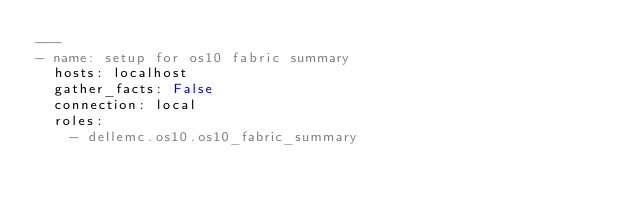Convert code to text. <code><loc_0><loc_0><loc_500><loc_500><_YAML_>---
- name: setup for os10 fabric summary
  hosts: localhost
  gather_facts: False
  connection: local
  roles:
    - dellemc.os10.os10_fabric_summary
</code> 